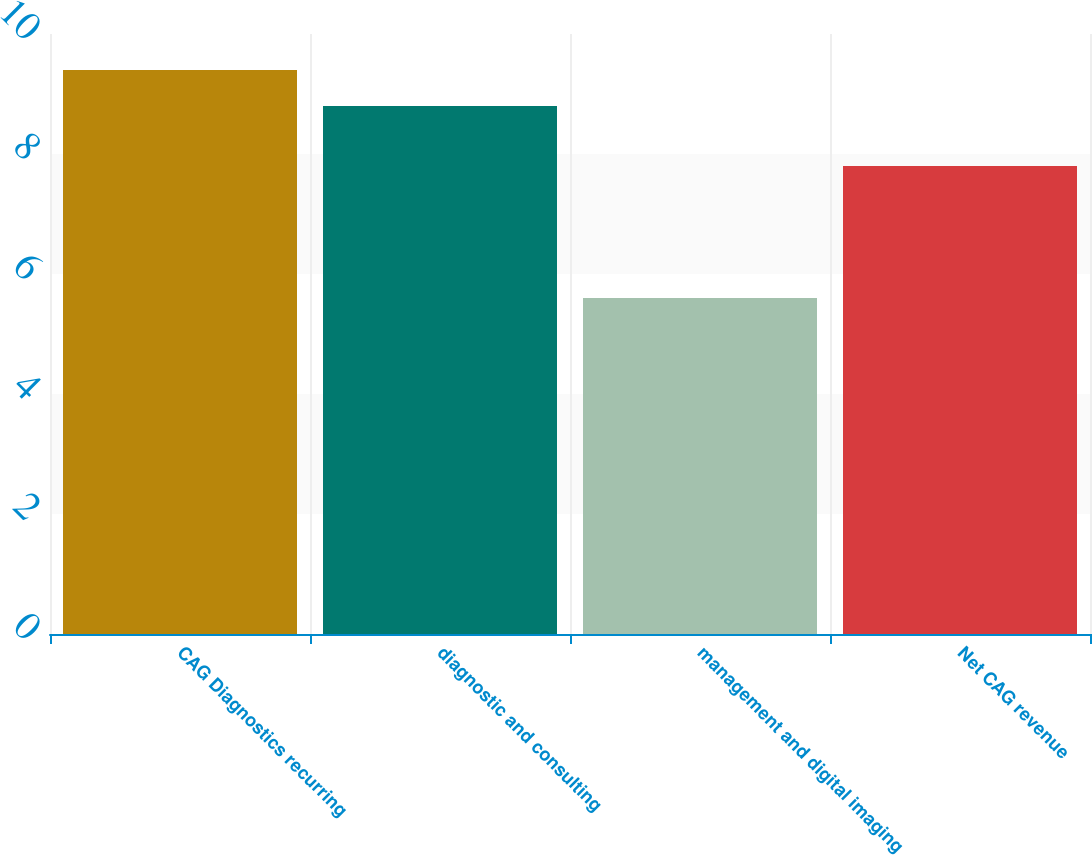<chart> <loc_0><loc_0><loc_500><loc_500><bar_chart><fcel>CAG Diagnostics recurring<fcel>diagnostic and consulting<fcel>management and digital imaging<fcel>Net CAG revenue<nl><fcel>9.4<fcel>8.8<fcel>5.6<fcel>7.8<nl></chart> 